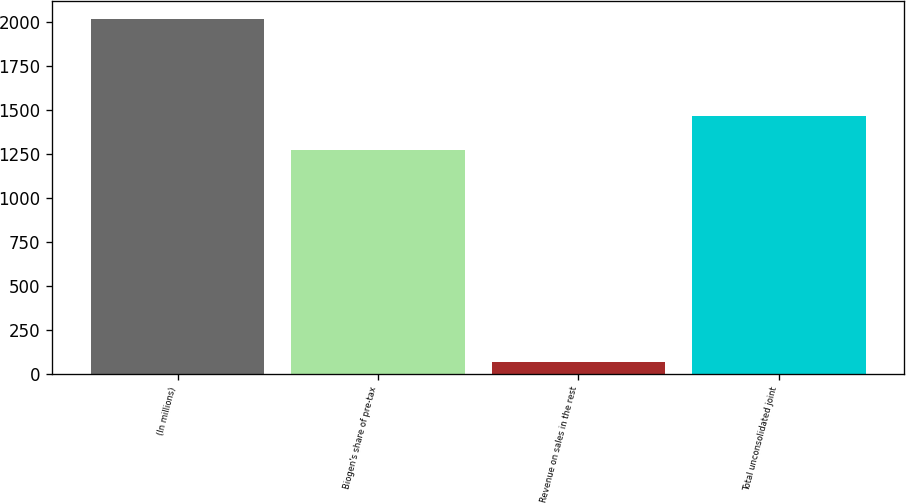<chart> <loc_0><loc_0><loc_500><loc_500><bar_chart><fcel>(In millions)<fcel>Biogen's share of pre-tax<fcel>Revenue on sales in the rest<fcel>Total unconsolidated joint<nl><fcel>2015<fcel>1269.8<fcel>69.4<fcel>1464.36<nl></chart> 